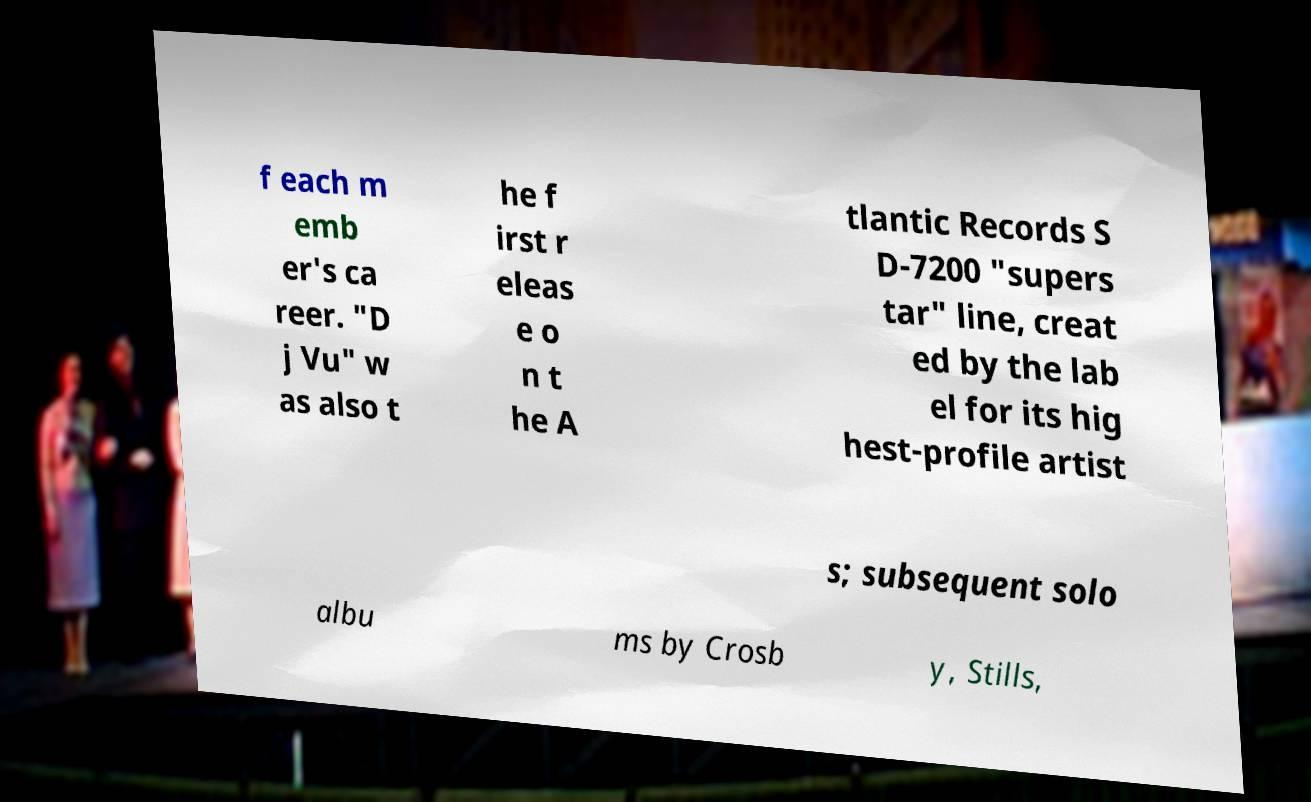I need the written content from this picture converted into text. Can you do that? f each m emb er's ca reer. "D j Vu" w as also t he f irst r eleas e o n t he A tlantic Records S D-7200 "supers tar" line, creat ed by the lab el for its hig hest-profile artist s; subsequent solo albu ms by Crosb y, Stills, 